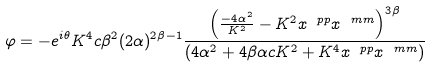Convert formula to latex. <formula><loc_0><loc_0><loc_500><loc_500>\varphi = - e ^ { i \theta } { K ^ { 4 } c \beta ^ { 2 } } ( 2 \alpha ) ^ { 2 \beta - 1 } \frac { \left ( \frac { - 4 \alpha ^ { 2 } } { K ^ { 2 } } - K ^ { 2 } { x ^ { \ p p } x ^ { \ m m } } \right ) ^ { 3 \beta } } { ( 4 \alpha ^ { 2 } + 4 \beta \alpha c K ^ { 2 } + K ^ { 4 } x ^ { \ p p } x ^ { \ m m } ) }</formula> 